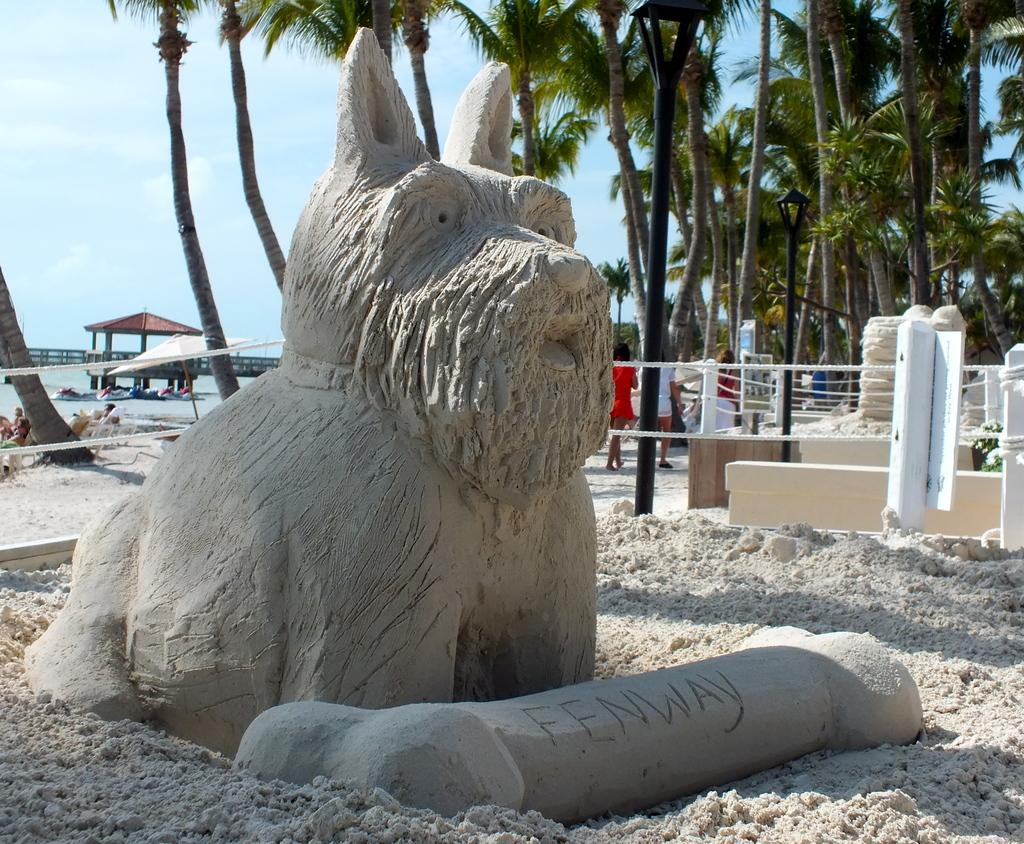What is the main subject of the statue in the image? The statue is of a dog holding a bone. Where is the statue located in the image? The statue is on the land. What color is the ribbon in the image? The ribbon in the image is white. Who is present in the image? There are people in the image. What can be seen in the background of the image? There are trees and the sky visible in the background of the image. What advice does the governor give to the hen in the image? There is no governor or hen present in the image; it features a statue of a dog holding a bone and people in the background. 